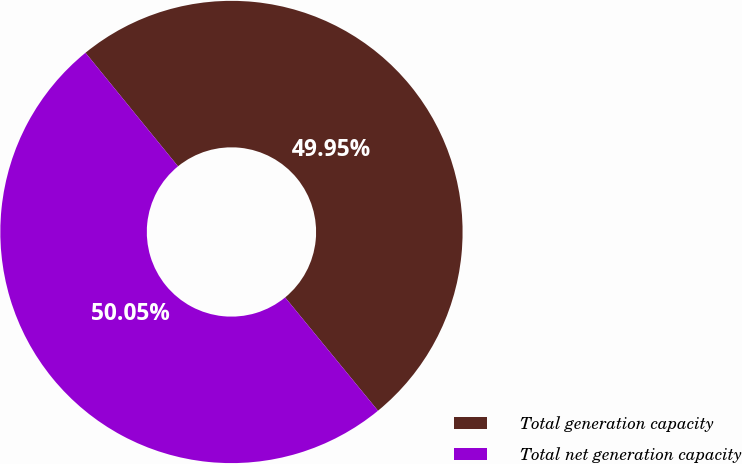Convert chart to OTSL. <chart><loc_0><loc_0><loc_500><loc_500><pie_chart><fcel>Total generation capacity<fcel>Total net generation capacity<nl><fcel>49.95%<fcel>50.05%<nl></chart> 